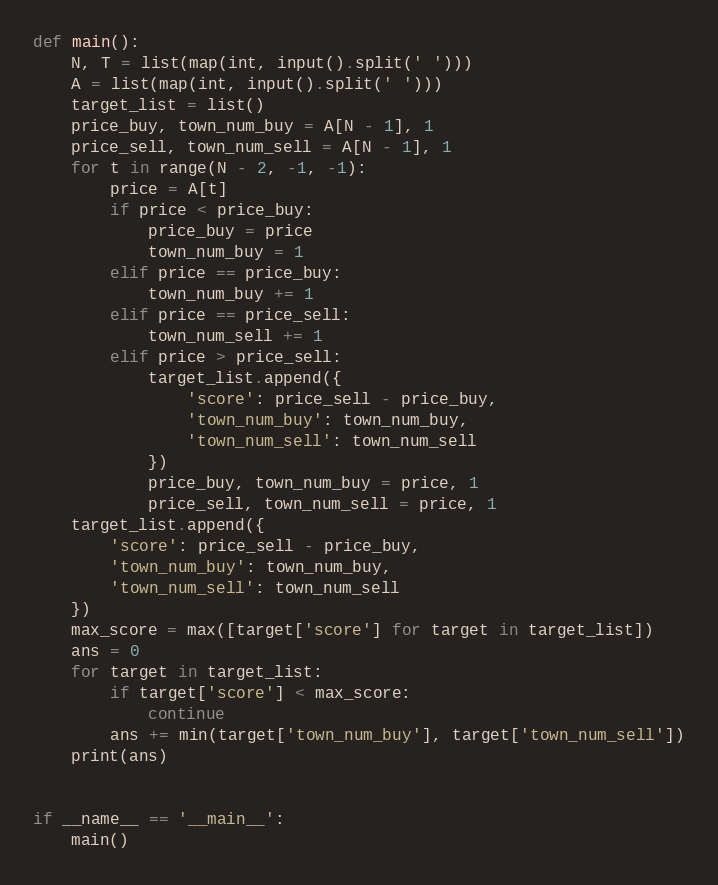Convert code to text. <code><loc_0><loc_0><loc_500><loc_500><_Python_>def main():
    N, T = list(map(int, input().split(' ')))
    A = list(map(int, input().split(' ')))
    target_list = list()
    price_buy, town_num_buy = A[N - 1], 1
    price_sell, town_num_sell = A[N - 1], 1
    for t in range(N - 2, -1, -1):
        price = A[t]
        if price < price_buy:
            price_buy = price
            town_num_buy = 1
        elif price == price_buy:
            town_num_buy += 1
        elif price == price_sell:
            town_num_sell += 1
        elif price > price_sell:
            target_list.append({
                'score': price_sell - price_buy,
                'town_num_buy': town_num_buy,
                'town_num_sell': town_num_sell
            })
            price_buy, town_num_buy = price, 1
            price_sell, town_num_sell = price, 1
    target_list.append({
        'score': price_sell - price_buy,
        'town_num_buy': town_num_buy,
        'town_num_sell': town_num_sell
    })
    max_score = max([target['score'] for target in target_list])
    ans = 0
    for target in target_list:
        if target['score'] < max_score:
            continue
        ans += min(target['town_num_buy'], target['town_num_sell'])
    print(ans)


if __name__ == '__main__':
    main()</code> 